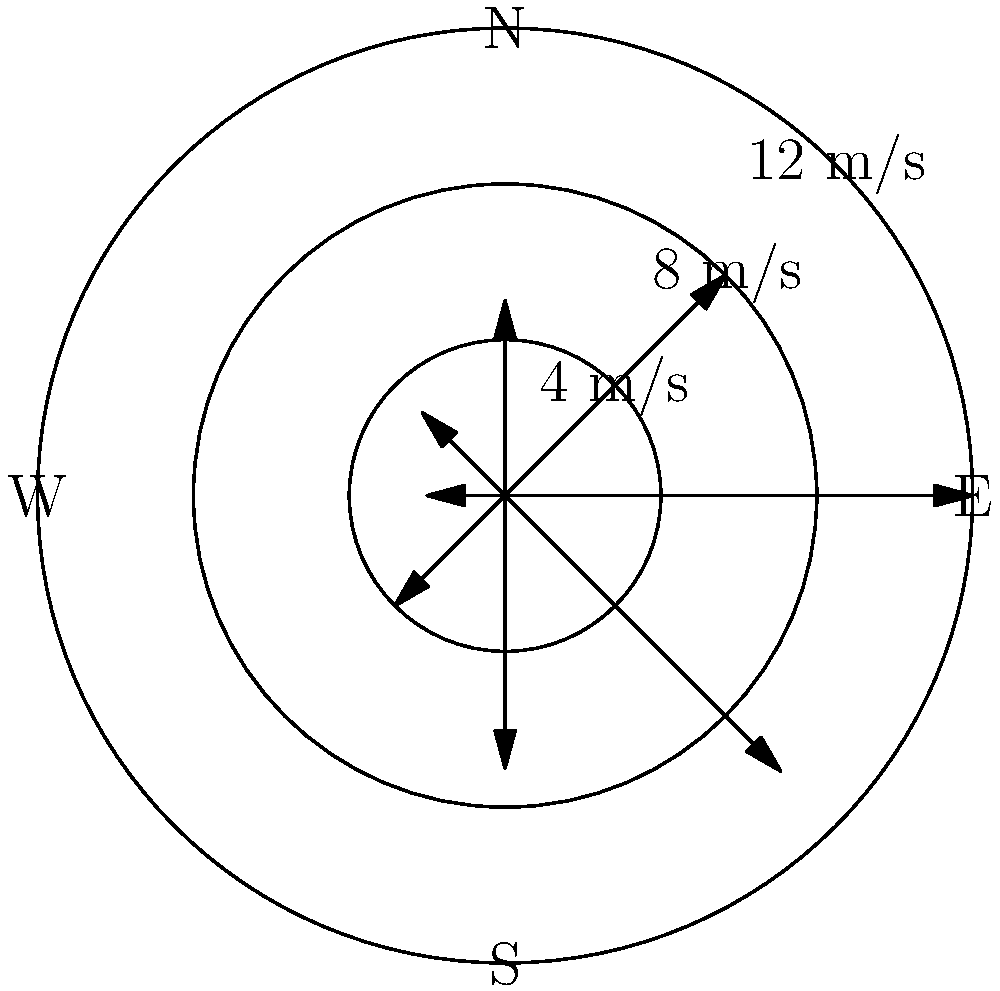Based on the wind rose diagram provided, which direction would be most suitable for placing a wind turbine to maximize energy production? To determine the optimal direction for wind turbine placement, we need to analyze the wind rose diagram:

1. The diagram shows wind speeds and directions over a period of time.
2. Longer arrows indicate higher wind speeds, which are more favorable for energy production.
3. We need to identify the direction with the highest consistent wind speeds.

Analyzing the diagram:
- North (0°): 12 m/s (highest speed)
- Northeast (45°): 8 m/s
- East (90°): 5 m/s
- Southeast (135°): 3 m/s
- South (180°): 2 m/s
- Southwest (225°): 4 m/s
- West (270°): 7 m/s
- Northwest (315°): 10 m/s

The highest wind speed is from the North at 12 m/s, followed by Northwest at 10 m/s. However, we should consider both speed and frequency.

The North and Northwest directions have the longest arrows, indicating they occur more frequently at higher speeds. Between these two, North has a slightly higher speed and longer arrow.

Therefore, placing the wind turbine to face North would likely maximize energy production by capturing the highest and most frequent wind speeds.
Answer: North 